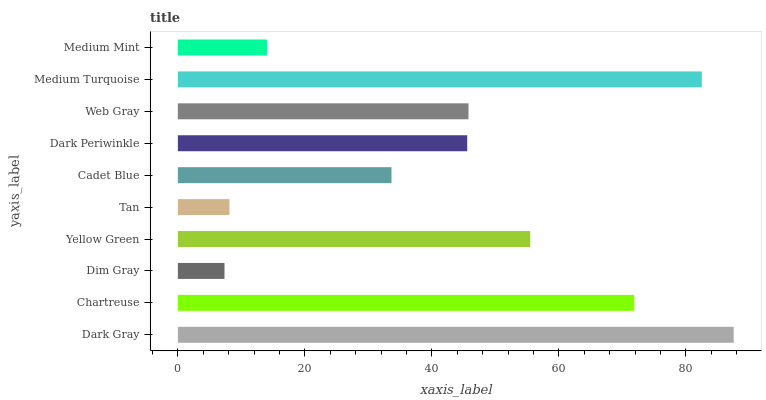Is Dim Gray the minimum?
Answer yes or no. Yes. Is Dark Gray the maximum?
Answer yes or no. Yes. Is Chartreuse the minimum?
Answer yes or no. No. Is Chartreuse the maximum?
Answer yes or no. No. Is Dark Gray greater than Chartreuse?
Answer yes or no. Yes. Is Chartreuse less than Dark Gray?
Answer yes or no. Yes. Is Chartreuse greater than Dark Gray?
Answer yes or no. No. Is Dark Gray less than Chartreuse?
Answer yes or no. No. Is Web Gray the high median?
Answer yes or no. Yes. Is Dark Periwinkle the low median?
Answer yes or no. Yes. Is Yellow Green the high median?
Answer yes or no. No. Is Web Gray the low median?
Answer yes or no. No. 